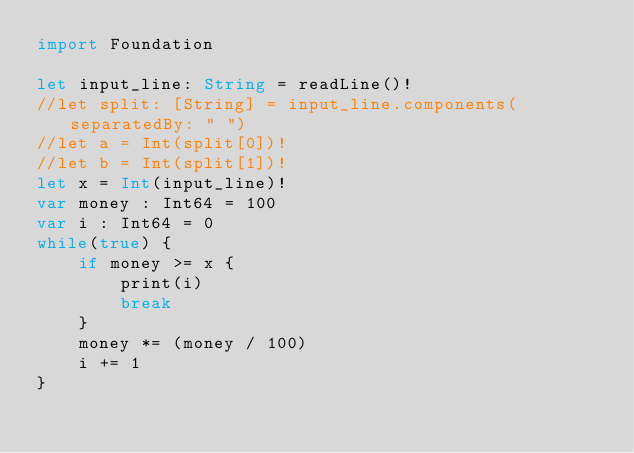Convert code to text. <code><loc_0><loc_0><loc_500><loc_500><_Swift_>import Foundation

let input_line: String = readLine()!
//let split: [String] = input_line.components(separatedBy: " ")
//let a = Int(split[0])!
//let b = Int(split[1])!
let x = Int(input_line)!
var money : Int64 = 100
var i : Int64 = 0
while(true) {
    if money >= x {
        print(i)
        break
    }
    money *= (money / 100)
    i += 1
}
</code> 